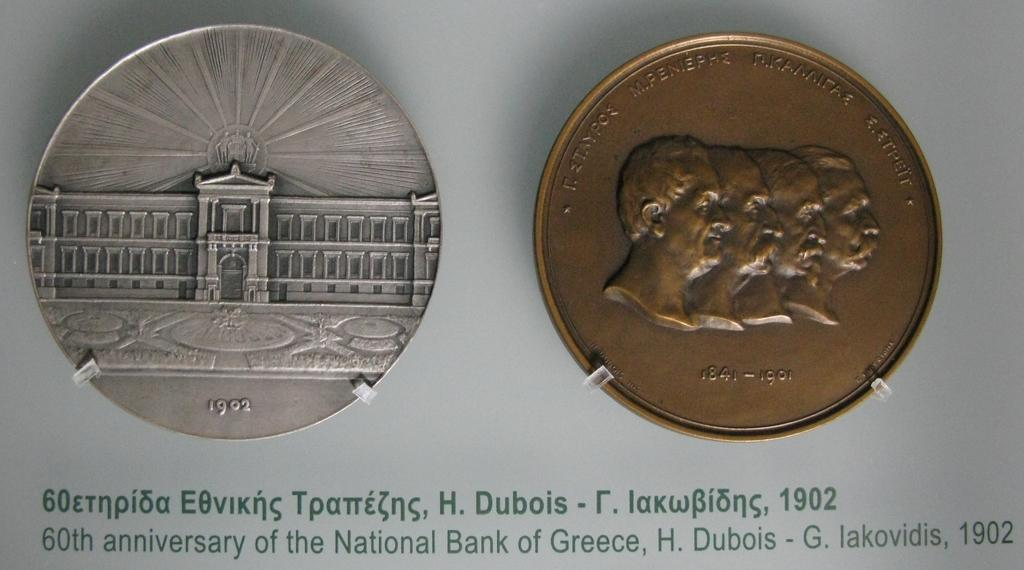Provide a one-sentence caption for the provided image. Two Greek coins from the early 1900s beside each other. 